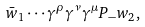Convert formula to latex. <formula><loc_0><loc_0><loc_500><loc_500>\bar { w } _ { 1 } \cdots \gamma ^ { \rho } \gamma ^ { \nu } \gamma ^ { \mu } P _ { - } w _ { 2 } ,</formula> 